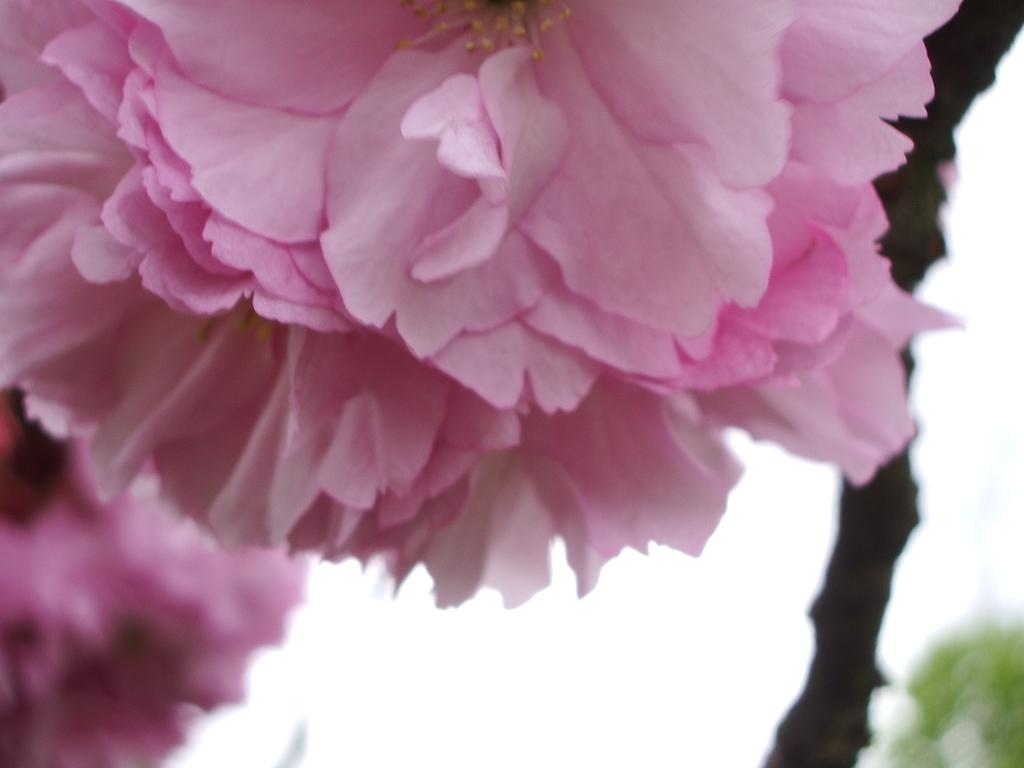What type of living organisms can be seen in the image? There are flowers in the image. How would you describe the background of the image? The background of the image is blurred. What colors are present in the image? White and green colors are present in the image. What type of roof can be seen in the image? There is no roof present in the image; it features flowers and a blurred background. Is there any sleet visible in the image? There is no sleet present in the image; it features flowers and a blurred background. 